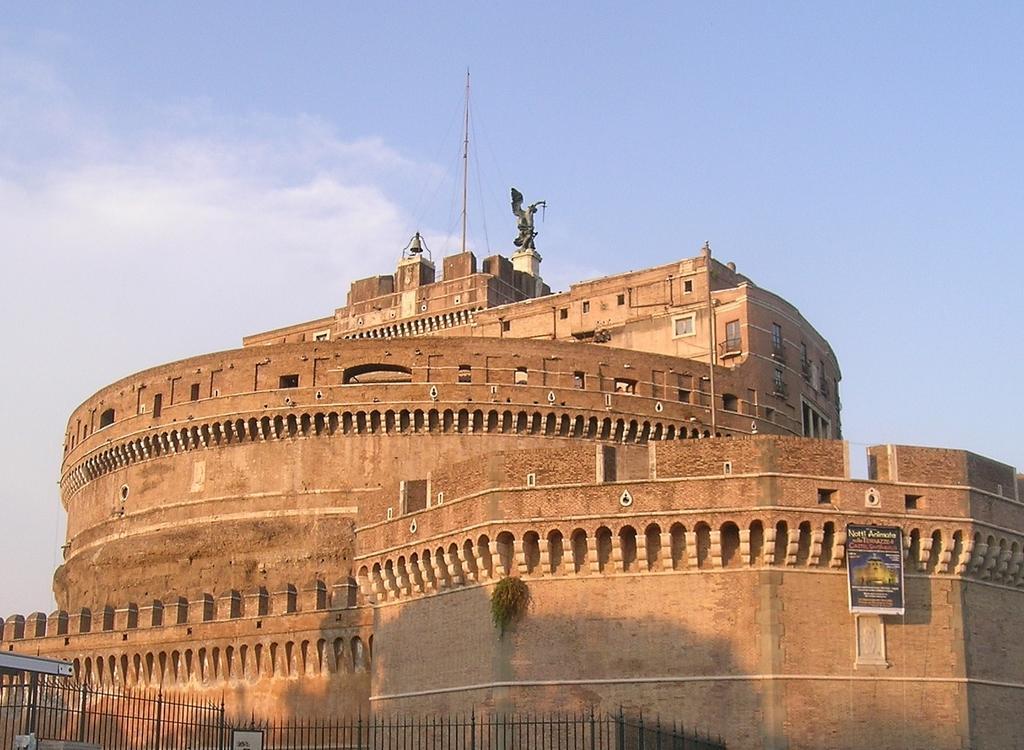Can you describe this image briefly? At the bottom of the image we can see few metal rods, on the right side of the image we can see a hoarding, in the background we can find a building and clouds. 